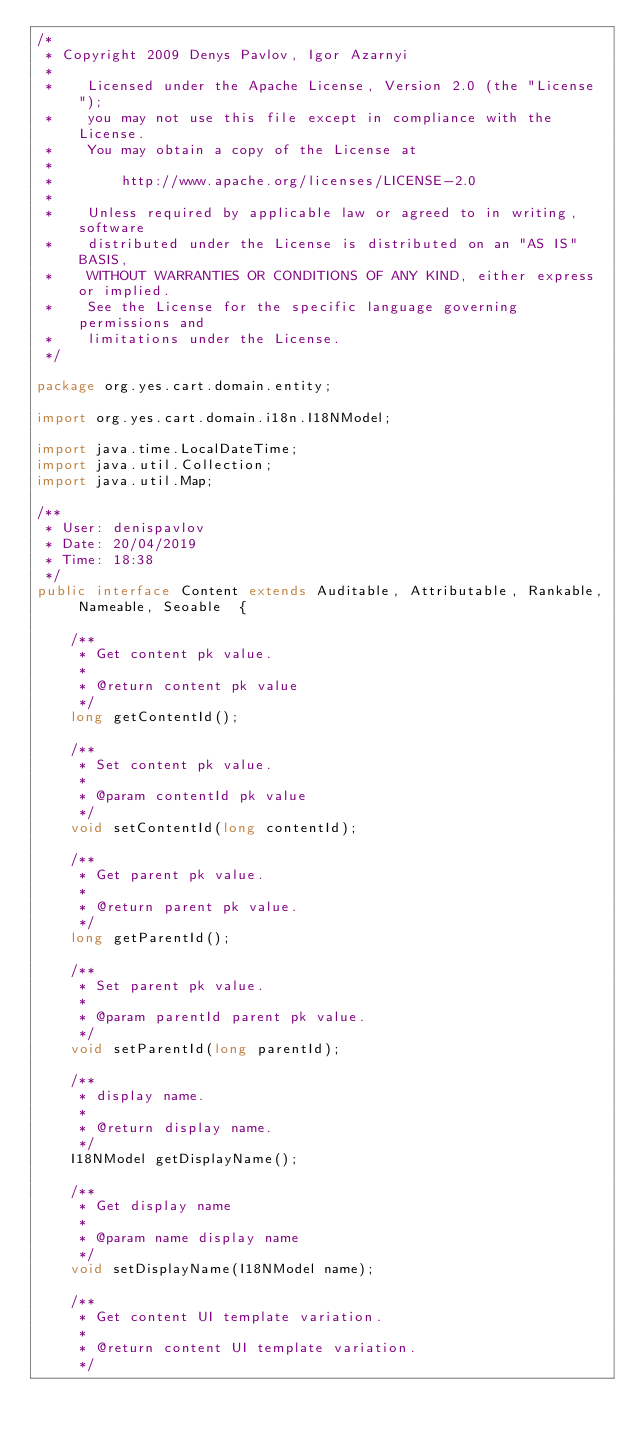Convert code to text. <code><loc_0><loc_0><loc_500><loc_500><_Java_>/*
 * Copyright 2009 Denys Pavlov, Igor Azarnyi
 *
 *    Licensed under the Apache License, Version 2.0 (the "License");
 *    you may not use this file except in compliance with the License.
 *    You may obtain a copy of the License at
 *
 *        http://www.apache.org/licenses/LICENSE-2.0
 *
 *    Unless required by applicable law or agreed to in writing, software
 *    distributed under the License is distributed on an "AS IS" BASIS,
 *    WITHOUT WARRANTIES OR CONDITIONS OF ANY KIND, either express or implied.
 *    See the License for the specific language governing permissions and
 *    limitations under the License.
 */

package org.yes.cart.domain.entity;

import org.yes.cart.domain.i18n.I18NModel;

import java.time.LocalDateTime;
import java.util.Collection;
import java.util.Map;

/**
 * User: denispavlov
 * Date: 20/04/2019
 * Time: 18:38
 */
public interface Content extends Auditable, Attributable, Rankable, Nameable, Seoable  {

    /**
     * Get content pk value.
     *
     * @return content pk value
     */
    long getContentId();

    /**
     * Set content pk value.
     *
     * @param contentId pk value
     */
    void setContentId(long contentId);

    /**
     * Get parent pk value.
     *
     * @return parent pk value.
     */
    long getParentId();

    /**
     * Set parent pk value.
     *
     * @param parentId parent pk value.
     */
    void setParentId(long parentId);

    /**
     * display name.
     *
     * @return display name.
     */
    I18NModel getDisplayName();

    /**
     * Get display name
     *
     * @param name display name
     */
    void setDisplayName(I18NModel name);

    /**
     * Get content UI template variation.
     *
     * @return content UI template variation.
     */</code> 